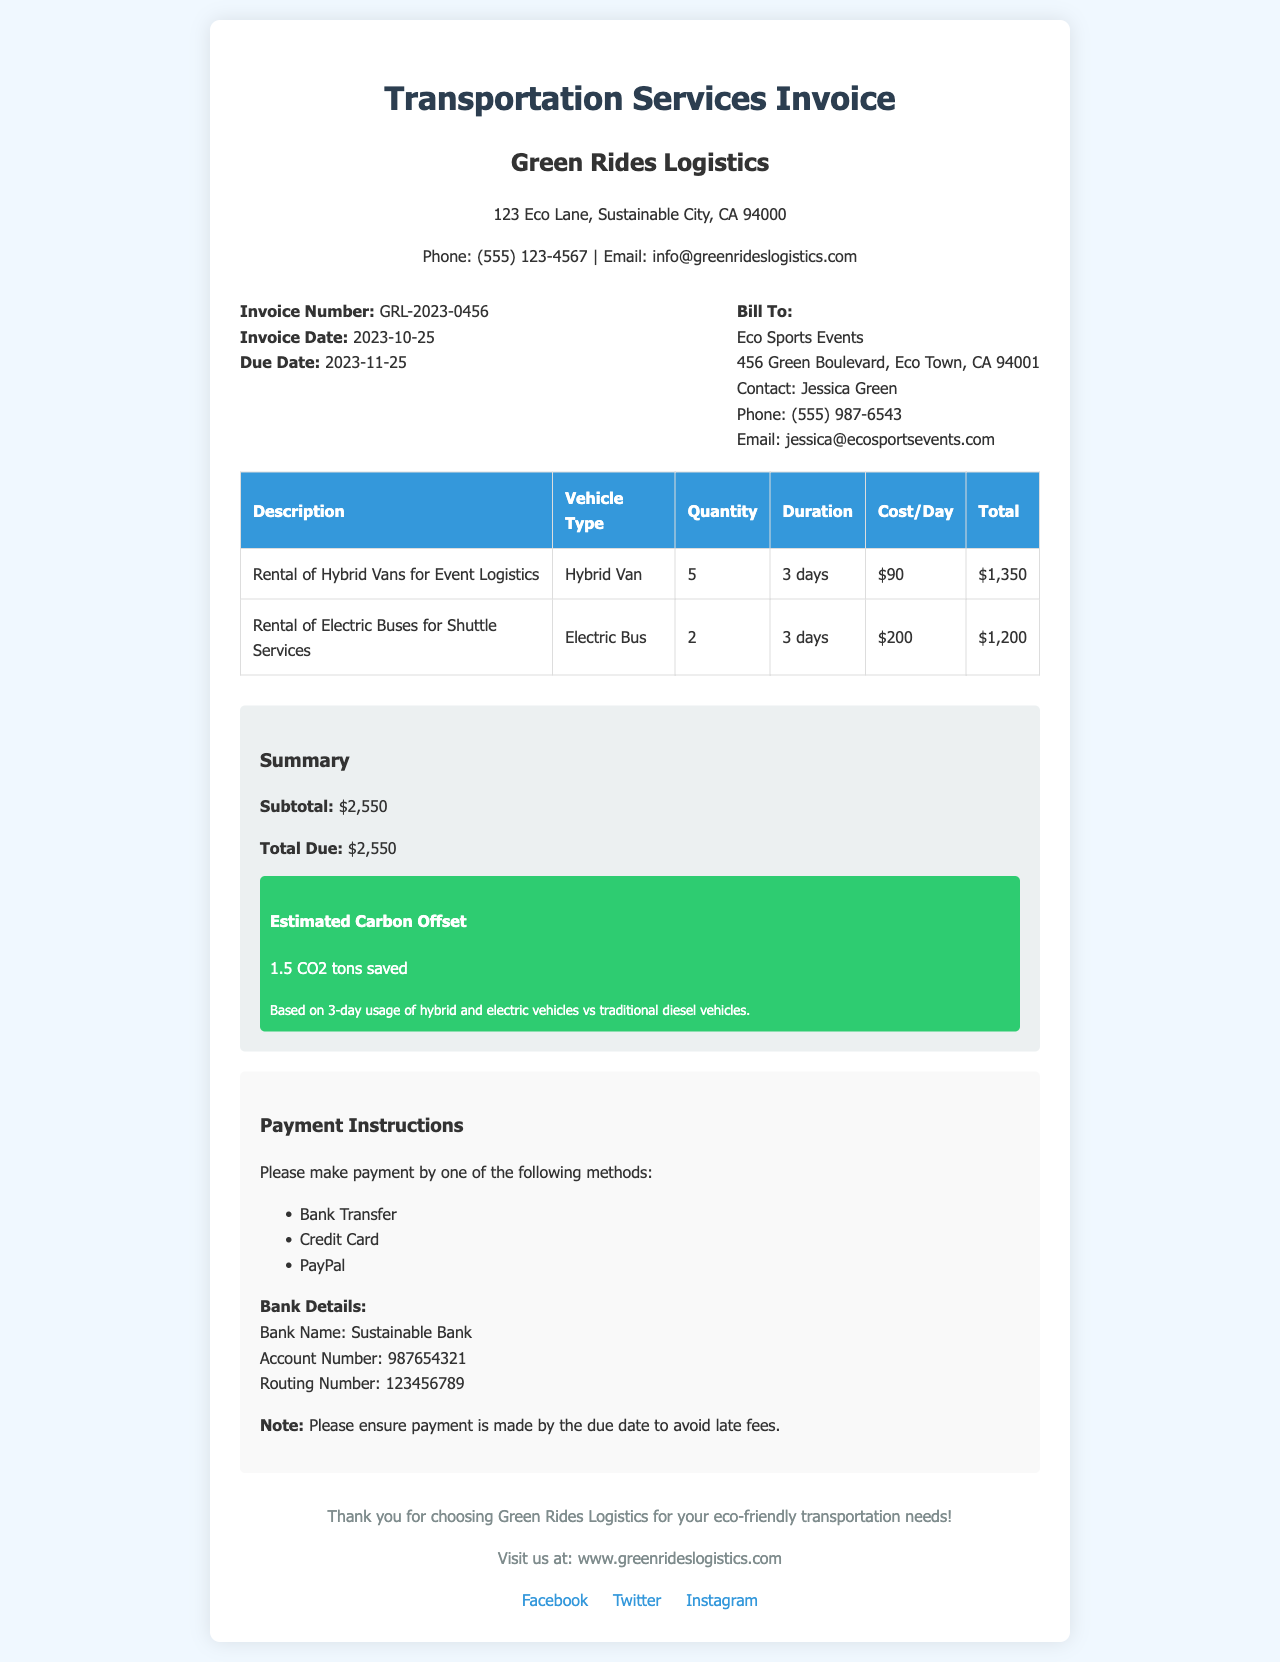What is the invoice number? The invoice number is found in the invoice details section and is a unique identifier for this document.
Answer: GRL-2023-0456 What is the due date for payment? The due date is specified in the document and indicates the last date to make the payment to avoid late fees.
Answer: 2023-11-25 How many hybrid vans are rented? The rental section lists the quantity of hybrid vans for the event logistics.
Answer: 5 What is the total cost for the electric buses? The total cost for the electric buses can be calculated based on the quantity and cost per day provided in the table.
Answer: $1,200 What is the subtotal amount on the invoice? The subtotal is a key part of the financial summary section of the invoice, showing the accumulated costs.
Answer: $2,550 How much CO2 is estimated to be saved? The estimated carbon offset is provided in the summary section and indicates the environmental benefit of using green vehicles.
Answer: 1.5 CO2 tons What type of vehicles are listed for rental services? This information is located in the services section and identifies the vehicles available for the event's logistics.
Answer: Hybrid Vans and Electric Buses What payment methods are accepted? The payment instructions section describes various methods for making a payment for the invoice.
Answer: Bank Transfer, Credit Card, PayPal 